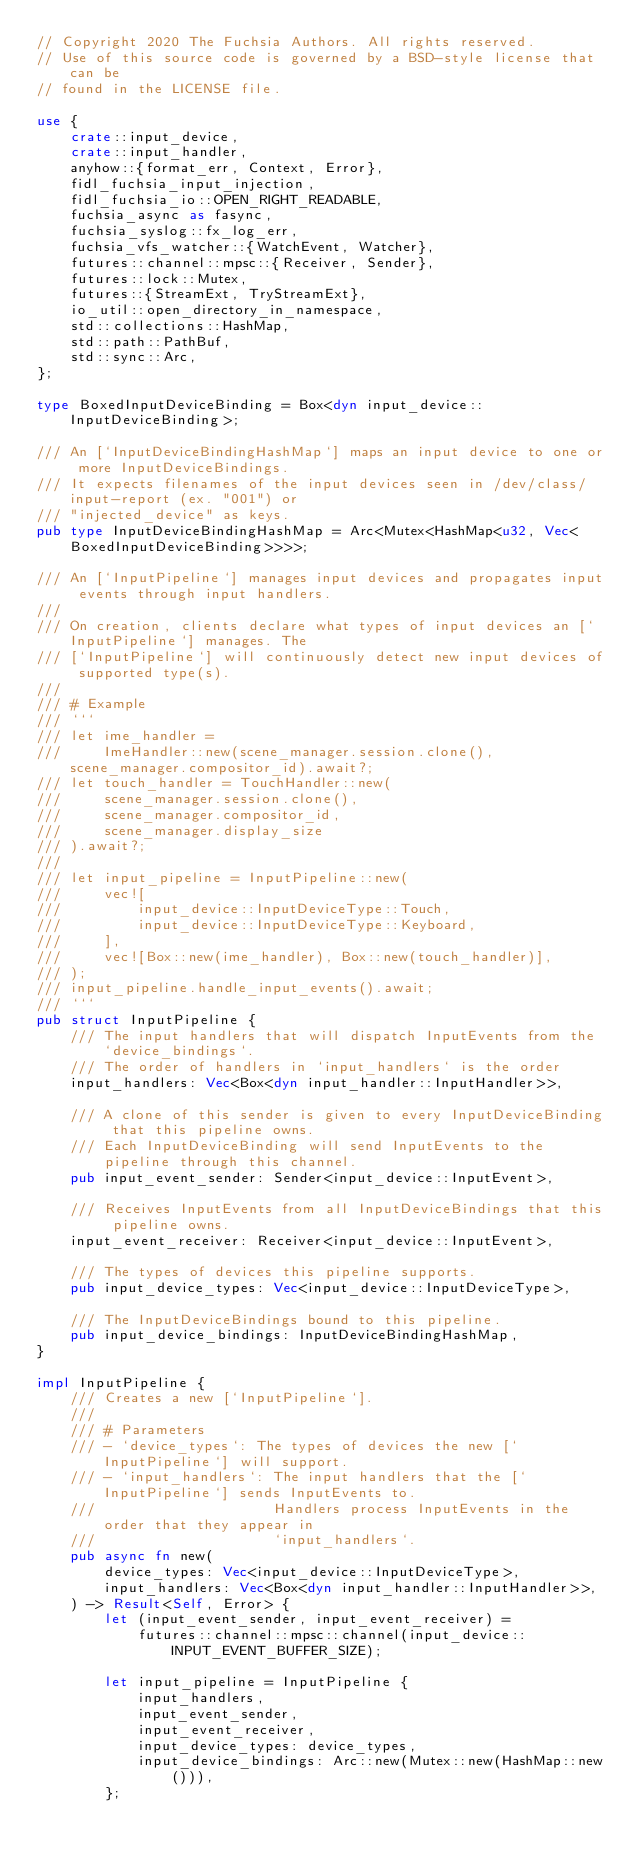Convert code to text. <code><loc_0><loc_0><loc_500><loc_500><_Rust_>// Copyright 2020 The Fuchsia Authors. All rights reserved.
// Use of this source code is governed by a BSD-style license that can be
// found in the LICENSE file.

use {
    crate::input_device,
    crate::input_handler,
    anyhow::{format_err, Context, Error},
    fidl_fuchsia_input_injection,
    fidl_fuchsia_io::OPEN_RIGHT_READABLE,
    fuchsia_async as fasync,
    fuchsia_syslog::fx_log_err,
    fuchsia_vfs_watcher::{WatchEvent, Watcher},
    futures::channel::mpsc::{Receiver, Sender},
    futures::lock::Mutex,
    futures::{StreamExt, TryStreamExt},
    io_util::open_directory_in_namespace,
    std::collections::HashMap,
    std::path::PathBuf,
    std::sync::Arc,
};

type BoxedInputDeviceBinding = Box<dyn input_device::InputDeviceBinding>;

/// An [`InputDeviceBindingHashMap`] maps an input device to one or more InputDeviceBindings.
/// It expects filenames of the input devices seen in /dev/class/input-report (ex. "001") or
/// "injected_device" as keys.
pub type InputDeviceBindingHashMap = Arc<Mutex<HashMap<u32, Vec<BoxedInputDeviceBinding>>>>;

/// An [`InputPipeline`] manages input devices and propagates input events through input handlers.
///
/// On creation, clients declare what types of input devices an [`InputPipeline`] manages. The
/// [`InputPipeline`] will continuously detect new input devices of supported type(s).
///
/// # Example
/// ```
/// let ime_handler =
///     ImeHandler::new(scene_manager.session.clone(), scene_manager.compositor_id).await?;
/// let touch_handler = TouchHandler::new(
///     scene_manager.session.clone(),
///     scene_manager.compositor_id,
///     scene_manager.display_size
/// ).await?;
///
/// let input_pipeline = InputPipeline::new(
///     vec![
///         input_device::InputDeviceType::Touch,
///         input_device::InputDeviceType::Keyboard,
///     ],
///     vec![Box::new(ime_handler), Box::new(touch_handler)],
/// );
/// input_pipeline.handle_input_events().await;
/// ```
pub struct InputPipeline {
    /// The input handlers that will dispatch InputEvents from the `device_bindings`.
    /// The order of handlers in `input_handlers` is the order
    input_handlers: Vec<Box<dyn input_handler::InputHandler>>,

    /// A clone of this sender is given to every InputDeviceBinding that this pipeline owns.
    /// Each InputDeviceBinding will send InputEvents to the pipeline through this channel.
    pub input_event_sender: Sender<input_device::InputEvent>,

    /// Receives InputEvents from all InputDeviceBindings that this pipeline owns.
    input_event_receiver: Receiver<input_device::InputEvent>,

    /// The types of devices this pipeline supports.
    pub input_device_types: Vec<input_device::InputDeviceType>,

    /// The InputDeviceBindings bound to this pipeline.
    pub input_device_bindings: InputDeviceBindingHashMap,
}

impl InputPipeline {
    /// Creates a new [`InputPipeline`].
    ///
    /// # Parameters
    /// - `device_types`: The types of devices the new [`InputPipeline`] will support.
    /// - `input_handlers`: The input handlers that the [`InputPipeline`] sends InputEvents to.
    ///                     Handlers process InputEvents in the order that they appear in
    ///                     `input_handlers`.
    pub async fn new(
        device_types: Vec<input_device::InputDeviceType>,
        input_handlers: Vec<Box<dyn input_handler::InputHandler>>,
    ) -> Result<Self, Error> {
        let (input_event_sender, input_event_receiver) =
            futures::channel::mpsc::channel(input_device::INPUT_EVENT_BUFFER_SIZE);

        let input_pipeline = InputPipeline {
            input_handlers,
            input_event_sender,
            input_event_receiver,
            input_device_types: device_types,
            input_device_bindings: Arc::new(Mutex::new(HashMap::new())),
        };
</code> 